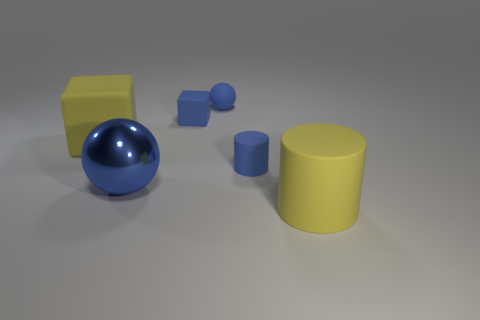The matte object that is the same color as the large cylinder is what shape?
Provide a succinct answer. Cube. How many large rubber things have the same shape as the big shiny thing?
Your response must be concise. 0. How many large rubber things are behind the big cylinder?
Your answer should be compact. 1. There is a small matte object that is behind the small matte cube; does it have the same color as the big sphere?
Give a very brief answer. Yes. What number of yellow matte cubes have the same size as the blue metallic sphere?
Keep it short and to the point. 1. There is a large yellow object that is the same material as the large cylinder; what shape is it?
Offer a very short reply. Cube. Are there any spheres of the same color as the small matte block?
Your answer should be very brief. Yes. What material is the large blue object?
Your answer should be compact. Metal. What number of things are either red metallic cylinders or blue matte things?
Keep it short and to the point. 3. What size is the blue sphere in front of the small ball?
Provide a short and direct response. Large. 